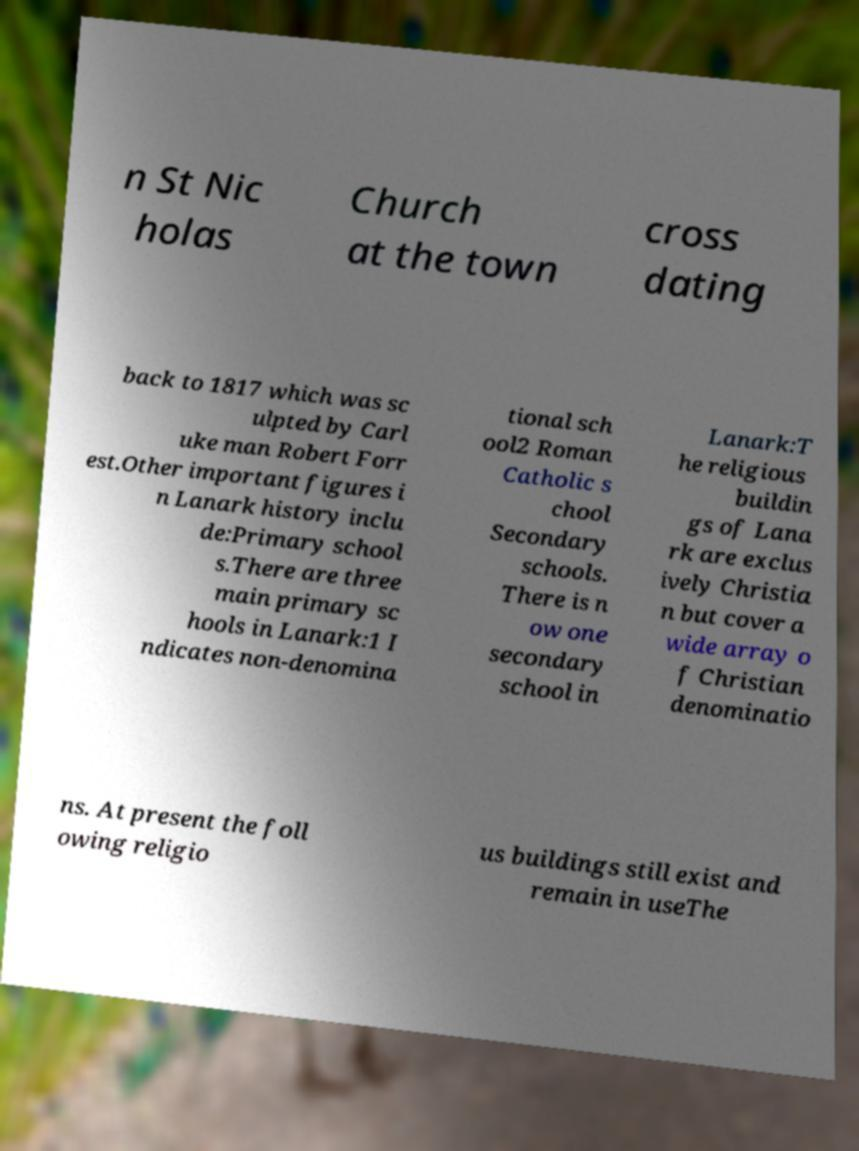Can you read and provide the text displayed in the image?This photo seems to have some interesting text. Can you extract and type it out for me? n St Nic holas Church at the town cross dating back to 1817 which was sc ulpted by Carl uke man Robert Forr est.Other important figures i n Lanark history inclu de:Primary school s.There are three main primary sc hools in Lanark:1 I ndicates non-denomina tional sch ool2 Roman Catholic s chool Secondary schools. There is n ow one secondary school in Lanark:T he religious buildin gs of Lana rk are exclus ively Christia n but cover a wide array o f Christian denominatio ns. At present the foll owing religio us buildings still exist and remain in useThe 